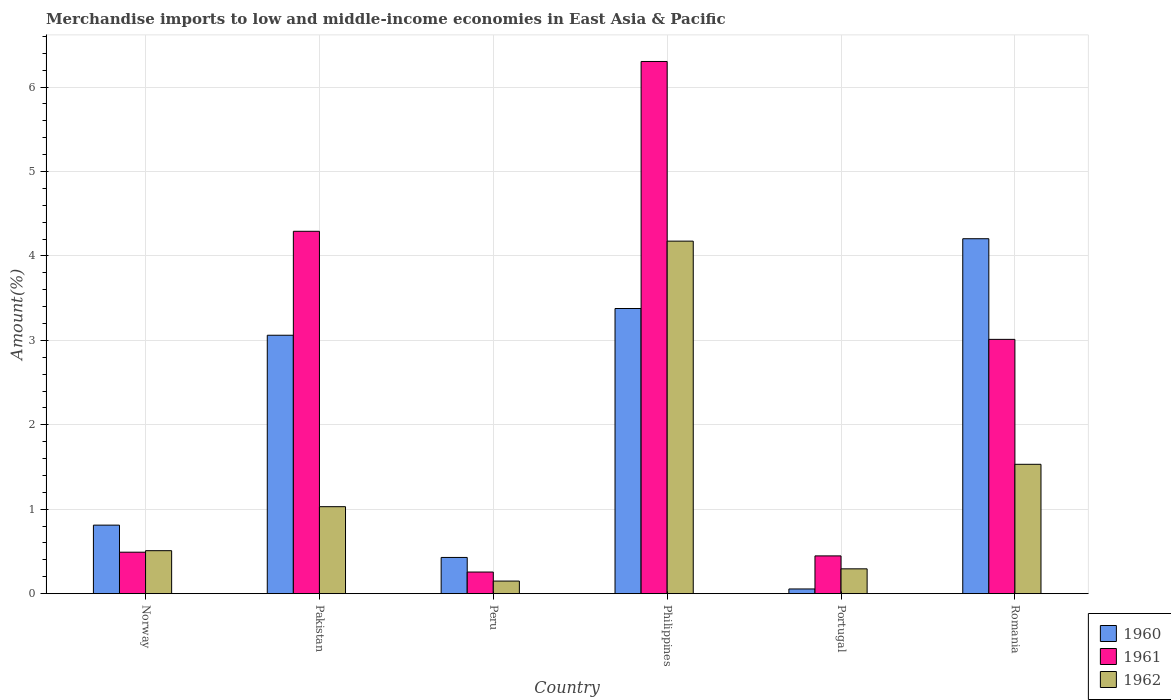How many different coloured bars are there?
Keep it short and to the point. 3. How many groups of bars are there?
Offer a very short reply. 6. Are the number of bars on each tick of the X-axis equal?
Provide a short and direct response. Yes. How many bars are there on the 1st tick from the left?
Provide a succinct answer. 3. How many bars are there on the 6th tick from the right?
Your answer should be very brief. 3. In how many cases, is the number of bars for a given country not equal to the number of legend labels?
Your answer should be very brief. 0. What is the percentage of amount earned from merchandise imports in 1961 in Romania?
Offer a terse response. 3.01. Across all countries, what is the maximum percentage of amount earned from merchandise imports in 1960?
Give a very brief answer. 4.2. Across all countries, what is the minimum percentage of amount earned from merchandise imports in 1961?
Keep it short and to the point. 0.26. What is the total percentage of amount earned from merchandise imports in 1960 in the graph?
Your answer should be compact. 11.94. What is the difference between the percentage of amount earned from merchandise imports in 1962 in Philippines and that in Romania?
Offer a terse response. 2.64. What is the difference between the percentage of amount earned from merchandise imports in 1962 in Portugal and the percentage of amount earned from merchandise imports in 1960 in Romania?
Offer a terse response. -3.91. What is the average percentage of amount earned from merchandise imports in 1962 per country?
Provide a short and direct response. 1.28. What is the difference between the percentage of amount earned from merchandise imports of/in 1962 and percentage of amount earned from merchandise imports of/in 1961 in Peru?
Provide a short and direct response. -0.11. What is the ratio of the percentage of amount earned from merchandise imports in 1962 in Norway to that in Philippines?
Your answer should be compact. 0.12. What is the difference between the highest and the second highest percentage of amount earned from merchandise imports in 1960?
Provide a short and direct response. -0.32. What is the difference between the highest and the lowest percentage of amount earned from merchandise imports in 1962?
Provide a succinct answer. 4.03. What does the 3rd bar from the right in Norway represents?
Your response must be concise. 1960. Are all the bars in the graph horizontal?
Your response must be concise. No. How many countries are there in the graph?
Your answer should be compact. 6. Are the values on the major ticks of Y-axis written in scientific E-notation?
Give a very brief answer. No. Where does the legend appear in the graph?
Make the answer very short. Bottom right. What is the title of the graph?
Offer a very short reply. Merchandise imports to low and middle-income economies in East Asia & Pacific. What is the label or title of the Y-axis?
Offer a terse response. Amount(%). What is the Amount(%) of 1960 in Norway?
Your response must be concise. 0.81. What is the Amount(%) of 1961 in Norway?
Ensure brevity in your answer.  0.49. What is the Amount(%) in 1962 in Norway?
Give a very brief answer. 0.51. What is the Amount(%) in 1960 in Pakistan?
Keep it short and to the point. 3.06. What is the Amount(%) of 1961 in Pakistan?
Offer a very short reply. 4.29. What is the Amount(%) in 1962 in Pakistan?
Offer a terse response. 1.03. What is the Amount(%) of 1960 in Peru?
Offer a terse response. 0.43. What is the Amount(%) of 1961 in Peru?
Offer a very short reply. 0.26. What is the Amount(%) in 1962 in Peru?
Ensure brevity in your answer.  0.15. What is the Amount(%) in 1960 in Philippines?
Make the answer very short. 3.38. What is the Amount(%) of 1961 in Philippines?
Ensure brevity in your answer.  6.3. What is the Amount(%) of 1962 in Philippines?
Make the answer very short. 4.18. What is the Amount(%) in 1960 in Portugal?
Make the answer very short. 0.06. What is the Amount(%) in 1961 in Portugal?
Offer a terse response. 0.45. What is the Amount(%) of 1962 in Portugal?
Provide a succinct answer. 0.29. What is the Amount(%) of 1960 in Romania?
Ensure brevity in your answer.  4.2. What is the Amount(%) in 1961 in Romania?
Make the answer very short. 3.01. What is the Amount(%) of 1962 in Romania?
Your response must be concise. 1.53. Across all countries, what is the maximum Amount(%) of 1960?
Keep it short and to the point. 4.2. Across all countries, what is the maximum Amount(%) of 1961?
Your response must be concise. 6.3. Across all countries, what is the maximum Amount(%) in 1962?
Ensure brevity in your answer.  4.18. Across all countries, what is the minimum Amount(%) in 1960?
Ensure brevity in your answer.  0.06. Across all countries, what is the minimum Amount(%) in 1961?
Offer a terse response. 0.26. Across all countries, what is the minimum Amount(%) of 1962?
Ensure brevity in your answer.  0.15. What is the total Amount(%) in 1960 in the graph?
Provide a succinct answer. 11.94. What is the total Amount(%) in 1961 in the graph?
Make the answer very short. 14.8. What is the total Amount(%) in 1962 in the graph?
Your response must be concise. 7.69. What is the difference between the Amount(%) in 1960 in Norway and that in Pakistan?
Your answer should be very brief. -2.25. What is the difference between the Amount(%) of 1961 in Norway and that in Pakistan?
Provide a succinct answer. -3.8. What is the difference between the Amount(%) of 1962 in Norway and that in Pakistan?
Your response must be concise. -0.52. What is the difference between the Amount(%) of 1960 in Norway and that in Peru?
Offer a terse response. 0.38. What is the difference between the Amount(%) in 1961 in Norway and that in Peru?
Ensure brevity in your answer.  0.24. What is the difference between the Amount(%) of 1962 in Norway and that in Peru?
Keep it short and to the point. 0.36. What is the difference between the Amount(%) of 1960 in Norway and that in Philippines?
Your answer should be compact. -2.57. What is the difference between the Amount(%) of 1961 in Norway and that in Philippines?
Your answer should be compact. -5.81. What is the difference between the Amount(%) in 1962 in Norway and that in Philippines?
Offer a terse response. -3.67. What is the difference between the Amount(%) in 1960 in Norway and that in Portugal?
Give a very brief answer. 0.76. What is the difference between the Amount(%) of 1961 in Norway and that in Portugal?
Your response must be concise. 0.04. What is the difference between the Amount(%) in 1962 in Norway and that in Portugal?
Provide a succinct answer. 0.22. What is the difference between the Amount(%) of 1960 in Norway and that in Romania?
Provide a succinct answer. -3.39. What is the difference between the Amount(%) of 1961 in Norway and that in Romania?
Your response must be concise. -2.52. What is the difference between the Amount(%) of 1962 in Norway and that in Romania?
Offer a terse response. -1.02. What is the difference between the Amount(%) in 1960 in Pakistan and that in Peru?
Offer a terse response. 2.63. What is the difference between the Amount(%) of 1961 in Pakistan and that in Peru?
Offer a very short reply. 4.04. What is the difference between the Amount(%) in 1962 in Pakistan and that in Peru?
Keep it short and to the point. 0.88. What is the difference between the Amount(%) of 1960 in Pakistan and that in Philippines?
Give a very brief answer. -0.32. What is the difference between the Amount(%) of 1961 in Pakistan and that in Philippines?
Keep it short and to the point. -2.01. What is the difference between the Amount(%) in 1962 in Pakistan and that in Philippines?
Provide a succinct answer. -3.15. What is the difference between the Amount(%) of 1960 in Pakistan and that in Portugal?
Offer a terse response. 3. What is the difference between the Amount(%) of 1961 in Pakistan and that in Portugal?
Ensure brevity in your answer.  3.84. What is the difference between the Amount(%) in 1962 in Pakistan and that in Portugal?
Your answer should be very brief. 0.74. What is the difference between the Amount(%) in 1960 in Pakistan and that in Romania?
Offer a very short reply. -1.14. What is the difference between the Amount(%) of 1961 in Pakistan and that in Romania?
Offer a very short reply. 1.28. What is the difference between the Amount(%) in 1962 in Pakistan and that in Romania?
Keep it short and to the point. -0.5. What is the difference between the Amount(%) of 1960 in Peru and that in Philippines?
Offer a very short reply. -2.95. What is the difference between the Amount(%) in 1961 in Peru and that in Philippines?
Make the answer very short. -6.05. What is the difference between the Amount(%) in 1962 in Peru and that in Philippines?
Your answer should be very brief. -4.03. What is the difference between the Amount(%) of 1960 in Peru and that in Portugal?
Offer a very short reply. 0.37. What is the difference between the Amount(%) of 1961 in Peru and that in Portugal?
Your answer should be very brief. -0.19. What is the difference between the Amount(%) of 1962 in Peru and that in Portugal?
Your answer should be very brief. -0.14. What is the difference between the Amount(%) of 1960 in Peru and that in Romania?
Keep it short and to the point. -3.77. What is the difference between the Amount(%) in 1961 in Peru and that in Romania?
Your answer should be very brief. -2.76. What is the difference between the Amount(%) in 1962 in Peru and that in Romania?
Provide a short and direct response. -1.38. What is the difference between the Amount(%) in 1960 in Philippines and that in Portugal?
Provide a short and direct response. 3.32. What is the difference between the Amount(%) of 1961 in Philippines and that in Portugal?
Offer a terse response. 5.86. What is the difference between the Amount(%) in 1962 in Philippines and that in Portugal?
Provide a succinct answer. 3.88. What is the difference between the Amount(%) in 1960 in Philippines and that in Romania?
Make the answer very short. -0.83. What is the difference between the Amount(%) in 1961 in Philippines and that in Romania?
Give a very brief answer. 3.29. What is the difference between the Amount(%) in 1962 in Philippines and that in Romania?
Give a very brief answer. 2.64. What is the difference between the Amount(%) in 1960 in Portugal and that in Romania?
Provide a succinct answer. -4.15. What is the difference between the Amount(%) of 1961 in Portugal and that in Romania?
Ensure brevity in your answer.  -2.56. What is the difference between the Amount(%) in 1962 in Portugal and that in Romania?
Offer a terse response. -1.24. What is the difference between the Amount(%) in 1960 in Norway and the Amount(%) in 1961 in Pakistan?
Offer a terse response. -3.48. What is the difference between the Amount(%) in 1960 in Norway and the Amount(%) in 1962 in Pakistan?
Your answer should be very brief. -0.22. What is the difference between the Amount(%) of 1961 in Norway and the Amount(%) of 1962 in Pakistan?
Your response must be concise. -0.54. What is the difference between the Amount(%) of 1960 in Norway and the Amount(%) of 1961 in Peru?
Ensure brevity in your answer.  0.56. What is the difference between the Amount(%) in 1960 in Norway and the Amount(%) in 1962 in Peru?
Offer a terse response. 0.66. What is the difference between the Amount(%) in 1961 in Norway and the Amount(%) in 1962 in Peru?
Your answer should be very brief. 0.34. What is the difference between the Amount(%) in 1960 in Norway and the Amount(%) in 1961 in Philippines?
Provide a short and direct response. -5.49. What is the difference between the Amount(%) of 1960 in Norway and the Amount(%) of 1962 in Philippines?
Keep it short and to the point. -3.36. What is the difference between the Amount(%) of 1961 in Norway and the Amount(%) of 1962 in Philippines?
Your response must be concise. -3.68. What is the difference between the Amount(%) in 1960 in Norway and the Amount(%) in 1961 in Portugal?
Provide a succinct answer. 0.36. What is the difference between the Amount(%) of 1960 in Norway and the Amount(%) of 1962 in Portugal?
Your response must be concise. 0.52. What is the difference between the Amount(%) of 1961 in Norway and the Amount(%) of 1962 in Portugal?
Make the answer very short. 0.2. What is the difference between the Amount(%) of 1960 in Norway and the Amount(%) of 1961 in Romania?
Provide a short and direct response. -2.2. What is the difference between the Amount(%) in 1960 in Norway and the Amount(%) in 1962 in Romania?
Your answer should be very brief. -0.72. What is the difference between the Amount(%) of 1961 in Norway and the Amount(%) of 1962 in Romania?
Your answer should be compact. -1.04. What is the difference between the Amount(%) of 1960 in Pakistan and the Amount(%) of 1961 in Peru?
Give a very brief answer. 2.8. What is the difference between the Amount(%) in 1960 in Pakistan and the Amount(%) in 1962 in Peru?
Offer a terse response. 2.91. What is the difference between the Amount(%) of 1961 in Pakistan and the Amount(%) of 1962 in Peru?
Keep it short and to the point. 4.14. What is the difference between the Amount(%) in 1960 in Pakistan and the Amount(%) in 1961 in Philippines?
Provide a succinct answer. -3.24. What is the difference between the Amount(%) of 1960 in Pakistan and the Amount(%) of 1962 in Philippines?
Give a very brief answer. -1.11. What is the difference between the Amount(%) in 1961 in Pakistan and the Amount(%) in 1962 in Philippines?
Your answer should be compact. 0.12. What is the difference between the Amount(%) of 1960 in Pakistan and the Amount(%) of 1961 in Portugal?
Offer a very short reply. 2.61. What is the difference between the Amount(%) of 1960 in Pakistan and the Amount(%) of 1962 in Portugal?
Offer a very short reply. 2.77. What is the difference between the Amount(%) in 1961 in Pakistan and the Amount(%) in 1962 in Portugal?
Your response must be concise. 4. What is the difference between the Amount(%) in 1960 in Pakistan and the Amount(%) in 1961 in Romania?
Provide a succinct answer. 0.05. What is the difference between the Amount(%) in 1960 in Pakistan and the Amount(%) in 1962 in Romania?
Keep it short and to the point. 1.53. What is the difference between the Amount(%) in 1961 in Pakistan and the Amount(%) in 1962 in Romania?
Provide a succinct answer. 2.76. What is the difference between the Amount(%) of 1960 in Peru and the Amount(%) of 1961 in Philippines?
Your answer should be compact. -5.87. What is the difference between the Amount(%) in 1960 in Peru and the Amount(%) in 1962 in Philippines?
Your response must be concise. -3.75. What is the difference between the Amount(%) in 1961 in Peru and the Amount(%) in 1962 in Philippines?
Give a very brief answer. -3.92. What is the difference between the Amount(%) of 1960 in Peru and the Amount(%) of 1961 in Portugal?
Give a very brief answer. -0.02. What is the difference between the Amount(%) of 1960 in Peru and the Amount(%) of 1962 in Portugal?
Offer a terse response. 0.14. What is the difference between the Amount(%) of 1961 in Peru and the Amount(%) of 1962 in Portugal?
Offer a terse response. -0.04. What is the difference between the Amount(%) in 1960 in Peru and the Amount(%) in 1961 in Romania?
Your response must be concise. -2.58. What is the difference between the Amount(%) in 1960 in Peru and the Amount(%) in 1962 in Romania?
Offer a very short reply. -1.1. What is the difference between the Amount(%) of 1961 in Peru and the Amount(%) of 1962 in Romania?
Offer a very short reply. -1.28. What is the difference between the Amount(%) in 1960 in Philippines and the Amount(%) in 1961 in Portugal?
Your answer should be compact. 2.93. What is the difference between the Amount(%) in 1960 in Philippines and the Amount(%) in 1962 in Portugal?
Offer a terse response. 3.08. What is the difference between the Amount(%) of 1961 in Philippines and the Amount(%) of 1962 in Portugal?
Keep it short and to the point. 6.01. What is the difference between the Amount(%) in 1960 in Philippines and the Amount(%) in 1961 in Romania?
Your answer should be very brief. 0.37. What is the difference between the Amount(%) in 1960 in Philippines and the Amount(%) in 1962 in Romania?
Your answer should be compact. 1.85. What is the difference between the Amount(%) in 1961 in Philippines and the Amount(%) in 1962 in Romania?
Your answer should be very brief. 4.77. What is the difference between the Amount(%) in 1960 in Portugal and the Amount(%) in 1961 in Romania?
Give a very brief answer. -2.96. What is the difference between the Amount(%) in 1960 in Portugal and the Amount(%) in 1962 in Romania?
Ensure brevity in your answer.  -1.48. What is the difference between the Amount(%) of 1961 in Portugal and the Amount(%) of 1962 in Romania?
Provide a short and direct response. -1.08. What is the average Amount(%) in 1960 per country?
Your response must be concise. 1.99. What is the average Amount(%) in 1961 per country?
Ensure brevity in your answer.  2.47. What is the average Amount(%) of 1962 per country?
Offer a terse response. 1.28. What is the difference between the Amount(%) of 1960 and Amount(%) of 1961 in Norway?
Give a very brief answer. 0.32. What is the difference between the Amount(%) in 1960 and Amount(%) in 1962 in Norway?
Offer a very short reply. 0.3. What is the difference between the Amount(%) of 1961 and Amount(%) of 1962 in Norway?
Offer a terse response. -0.02. What is the difference between the Amount(%) in 1960 and Amount(%) in 1961 in Pakistan?
Offer a terse response. -1.23. What is the difference between the Amount(%) in 1960 and Amount(%) in 1962 in Pakistan?
Provide a succinct answer. 2.03. What is the difference between the Amount(%) in 1961 and Amount(%) in 1962 in Pakistan?
Your response must be concise. 3.26. What is the difference between the Amount(%) in 1960 and Amount(%) in 1961 in Peru?
Offer a terse response. 0.17. What is the difference between the Amount(%) in 1960 and Amount(%) in 1962 in Peru?
Offer a very short reply. 0.28. What is the difference between the Amount(%) in 1961 and Amount(%) in 1962 in Peru?
Your response must be concise. 0.11. What is the difference between the Amount(%) in 1960 and Amount(%) in 1961 in Philippines?
Offer a terse response. -2.93. What is the difference between the Amount(%) in 1960 and Amount(%) in 1962 in Philippines?
Keep it short and to the point. -0.8. What is the difference between the Amount(%) of 1961 and Amount(%) of 1962 in Philippines?
Your answer should be very brief. 2.13. What is the difference between the Amount(%) of 1960 and Amount(%) of 1961 in Portugal?
Keep it short and to the point. -0.39. What is the difference between the Amount(%) in 1960 and Amount(%) in 1962 in Portugal?
Offer a terse response. -0.24. What is the difference between the Amount(%) of 1961 and Amount(%) of 1962 in Portugal?
Make the answer very short. 0.15. What is the difference between the Amount(%) in 1960 and Amount(%) in 1961 in Romania?
Offer a very short reply. 1.19. What is the difference between the Amount(%) in 1960 and Amount(%) in 1962 in Romania?
Your answer should be very brief. 2.67. What is the difference between the Amount(%) of 1961 and Amount(%) of 1962 in Romania?
Offer a very short reply. 1.48. What is the ratio of the Amount(%) in 1960 in Norway to that in Pakistan?
Your answer should be compact. 0.27. What is the ratio of the Amount(%) of 1961 in Norway to that in Pakistan?
Offer a terse response. 0.11. What is the ratio of the Amount(%) of 1962 in Norway to that in Pakistan?
Give a very brief answer. 0.49. What is the ratio of the Amount(%) of 1960 in Norway to that in Peru?
Your answer should be very brief. 1.89. What is the ratio of the Amount(%) of 1961 in Norway to that in Peru?
Offer a terse response. 1.92. What is the ratio of the Amount(%) in 1962 in Norway to that in Peru?
Ensure brevity in your answer.  3.41. What is the ratio of the Amount(%) of 1960 in Norway to that in Philippines?
Provide a succinct answer. 0.24. What is the ratio of the Amount(%) in 1961 in Norway to that in Philippines?
Provide a succinct answer. 0.08. What is the ratio of the Amount(%) of 1962 in Norway to that in Philippines?
Offer a terse response. 0.12. What is the ratio of the Amount(%) of 1960 in Norway to that in Portugal?
Give a very brief answer. 14.6. What is the ratio of the Amount(%) in 1961 in Norway to that in Portugal?
Keep it short and to the point. 1.1. What is the ratio of the Amount(%) of 1962 in Norway to that in Portugal?
Make the answer very short. 1.73. What is the ratio of the Amount(%) in 1960 in Norway to that in Romania?
Your response must be concise. 0.19. What is the ratio of the Amount(%) in 1961 in Norway to that in Romania?
Offer a very short reply. 0.16. What is the ratio of the Amount(%) of 1962 in Norway to that in Romania?
Offer a very short reply. 0.33. What is the ratio of the Amount(%) of 1960 in Pakistan to that in Peru?
Give a very brief answer. 7.13. What is the ratio of the Amount(%) in 1961 in Pakistan to that in Peru?
Keep it short and to the point. 16.76. What is the ratio of the Amount(%) in 1962 in Pakistan to that in Peru?
Keep it short and to the point. 6.91. What is the ratio of the Amount(%) in 1960 in Pakistan to that in Philippines?
Your answer should be very brief. 0.91. What is the ratio of the Amount(%) of 1961 in Pakistan to that in Philippines?
Give a very brief answer. 0.68. What is the ratio of the Amount(%) in 1962 in Pakistan to that in Philippines?
Offer a terse response. 0.25. What is the ratio of the Amount(%) of 1960 in Pakistan to that in Portugal?
Ensure brevity in your answer.  55.04. What is the ratio of the Amount(%) of 1961 in Pakistan to that in Portugal?
Your response must be concise. 9.6. What is the ratio of the Amount(%) of 1962 in Pakistan to that in Portugal?
Offer a very short reply. 3.5. What is the ratio of the Amount(%) of 1960 in Pakistan to that in Romania?
Offer a very short reply. 0.73. What is the ratio of the Amount(%) of 1961 in Pakistan to that in Romania?
Your answer should be very brief. 1.43. What is the ratio of the Amount(%) in 1962 in Pakistan to that in Romania?
Provide a succinct answer. 0.67. What is the ratio of the Amount(%) in 1960 in Peru to that in Philippines?
Your answer should be very brief. 0.13. What is the ratio of the Amount(%) in 1961 in Peru to that in Philippines?
Provide a succinct answer. 0.04. What is the ratio of the Amount(%) in 1962 in Peru to that in Philippines?
Your answer should be compact. 0.04. What is the ratio of the Amount(%) in 1960 in Peru to that in Portugal?
Offer a terse response. 7.71. What is the ratio of the Amount(%) in 1961 in Peru to that in Portugal?
Your answer should be very brief. 0.57. What is the ratio of the Amount(%) of 1962 in Peru to that in Portugal?
Your response must be concise. 0.51. What is the ratio of the Amount(%) of 1960 in Peru to that in Romania?
Offer a terse response. 0.1. What is the ratio of the Amount(%) in 1961 in Peru to that in Romania?
Provide a short and direct response. 0.09. What is the ratio of the Amount(%) of 1962 in Peru to that in Romania?
Offer a terse response. 0.1. What is the ratio of the Amount(%) in 1960 in Philippines to that in Portugal?
Provide a short and direct response. 60.74. What is the ratio of the Amount(%) of 1961 in Philippines to that in Portugal?
Your response must be concise. 14.09. What is the ratio of the Amount(%) in 1962 in Philippines to that in Portugal?
Offer a very short reply. 14.2. What is the ratio of the Amount(%) of 1960 in Philippines to that in Romania?
Keep it short and to the point. 0.8. What is the ratio of the Amount(%) in 1961 in Philippines to that in Romania?
Keep it short and to the point. 2.09. What is the ratio of the Amount(%) of 1962 in Philippines to that in Romania?
Your answer should be very brief. 2.73. What is the ratio of the Amount(%) of 1960 in Portugal to that in Romania?
Ensure brevity in your answer.  0.01. What is the ratio of the Amount(%) of 1961 in Portugal to that in Romania?
Offer a terse response. 0.15. What is the ratio of the Amount(%) of 1962 in Portugal to that in Romania?
Offer a terse response. 0.19. What is the difference between the highest and the second highest Amount(%) of 1960?
Your answer should be very brief. 0.83. What is the difference between the highest and the second highest Amount(%) of 1961?
Ensure brevity in your answer.  2.01. What is the difference between the highest and the second highest Amount(%) in 1962?
Offer a terse response. 2.64. What is the difference between the highest and the lowest Amount(%) of 1960?
Ensure brevity in your answer.  4.15. What is the difference between the highest and the lowest Amount(%) of 1961?
Offer a terse response. 6.05. What is the difference between the highest and the lowest Amount(%) of 1962?
Your answer should be very brief. 4.03. 